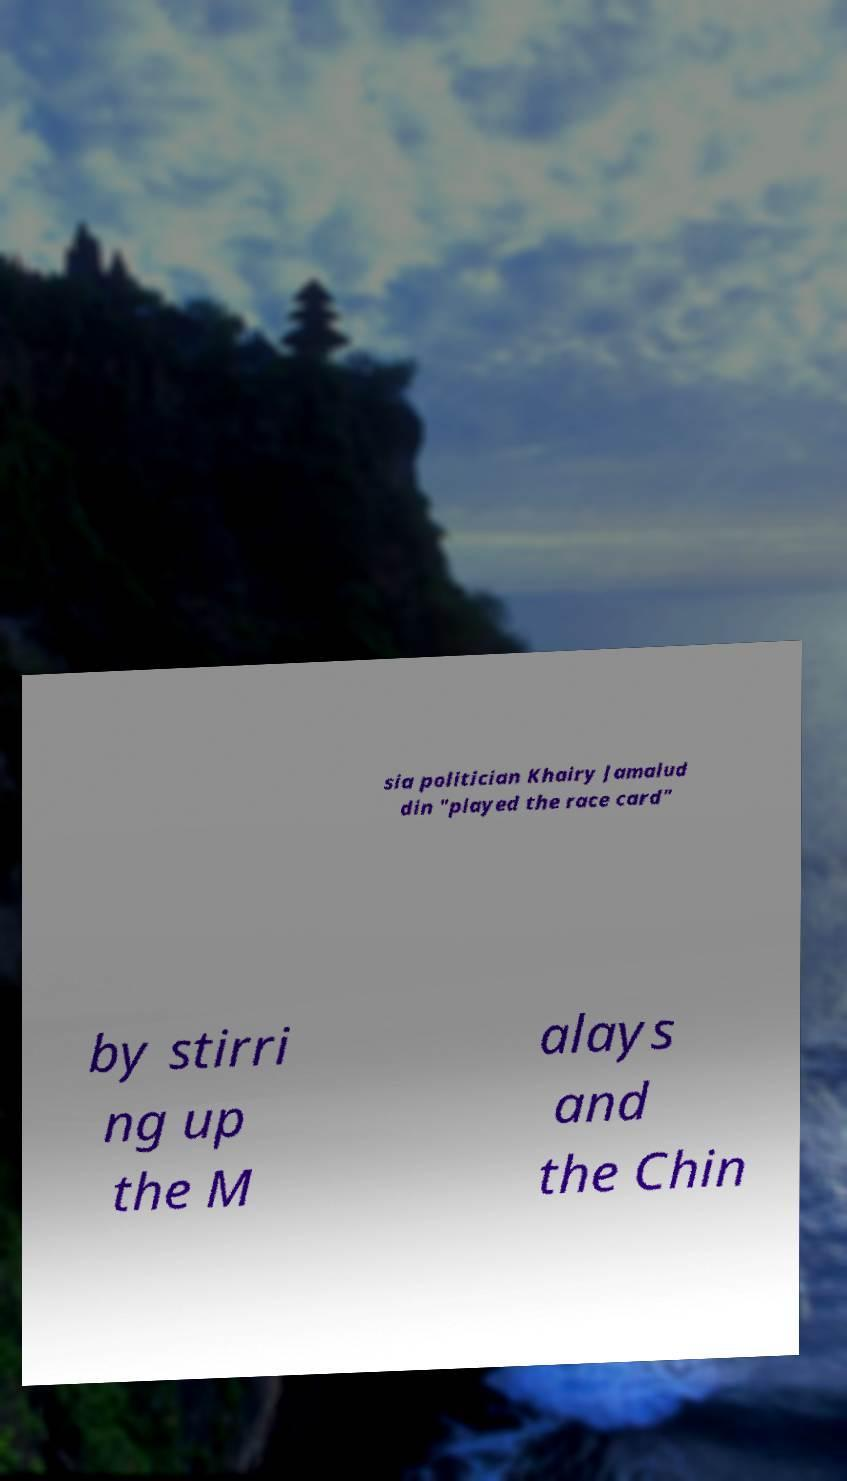There's text embedded in this image that I need extracted. Can you transcribe it verbatim? sia politician Khairy Jamalud din "played the race card" by stirri ng up the M alays and the Chin 